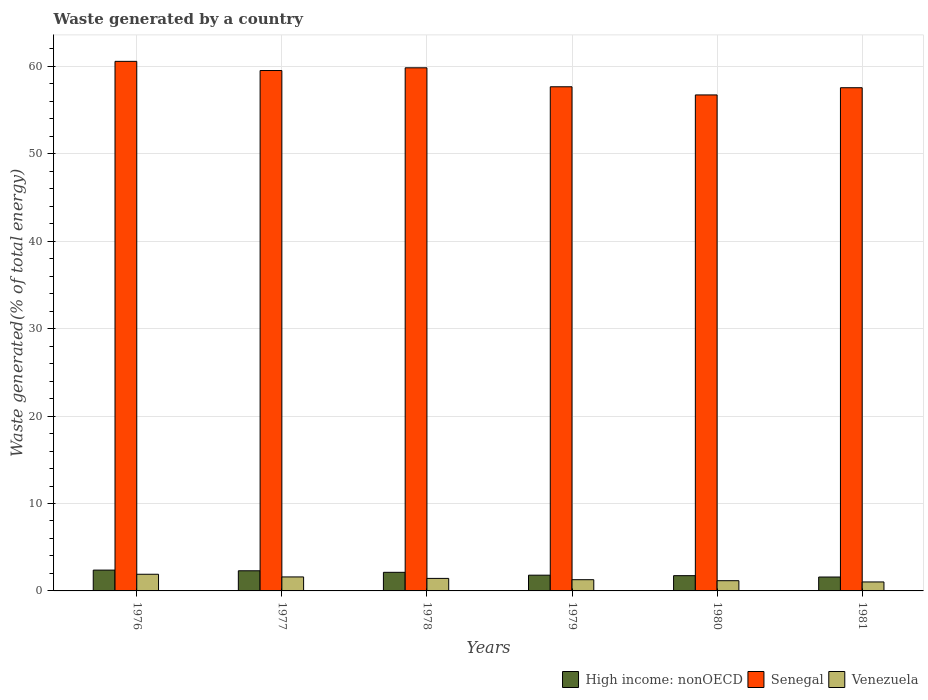How many different coloured bars are there?
Your answer should be compact. 3. How many groups of bars are there?
Your answer should be very brief. 6. Are the number of bars per tick equal to the number of legend labels?
Your response must be concise. Yes. How many bars are there on the 4th tick from the right?
Your response must be concise. 3. What is the label of the 2nd group of bars from the left?
Offer a very short reply. 1977. In how many cases, is the number of bars for a given year not equal to the number of legend labels?
Provide a short and direct response. 0. What is the total waste generated in Senegal in 1981?
Ensure brevity in your answer.  57.56. Across all years, what is the maximum total waste generated in Venezuela?
Offer a terse response. 1.91. Across all years, what is the minimum total waste generated in Senegal?
Ensure brevity in your answer.  56.74. In which year was the total waste generated in Venezuela maximum?
Provide a succinct answer. 1976. What is the total total waste generated in High income: nonOECD in the graph?
Make the answer very short. 11.95. What is the difference between the total waste generated in High income: nonOECD in 1976 and that in 1981?
Ensure brevity in your answer.  0.79. What is the difference between the total waste generated in Venezuela in 1976 and the total waste generated in Senegal in 1978?
Provide a succinct answer. -57.94. What is the average total waste generated in Venezuela per year?
Your answer should be compact. 1.4. In the year 1980, what is the difference between the total waste generated in Senegal and total waste generated in High income: nonOECD?
Give a very brief answer. 55. What is the ratio of the total waste generated in High income: nonOECD in 1976 to that in 1981?
Offer a terse response. 1.5. Is the difference between the total waste generated in Senegal in 1977 and 1978 greater than the difference between the total waste generated in High income: nonOECD in 1977 and 1978?
Provide a short and direct response. No. What is the difference between the highest and the second highest total waste generated in Senegal?
Your answer should be very brief. 0.74. What is the difference between the highest and the lowest total waste generated in High income: nonOECD?
Keep it short and to the point. 0.79. In how many years, is the total waste generated in High income: nonOECD greater than the average total waste generated in High income: nonOECD taken over all years?
Your response must be concise. 3. Is the sum of the total waste generated in High income: nonOECD in 1978 and 1981 greater than the maximum total waste generated in Venezuela across all years?
Make the answer very short. Yes. What does the 2nd bar from the left in 1977 represents?
Give a very brief answer. Senegal. What does the 2nd bar from the right in 1978 represents?
Offer a very short reply. Senegal. Is it the case that in every year, the sum of the total waste generated in Senegal and total waste generated in High income: nonOECD is greater than the total waste generated in Venezuela?
Your response must be concise. Yes. Are all the bars in the graph horizontal?
Keep it short and to the point. No. Does the graph contain grids?
Keep it short and to the point. Yes. How many legend labels are there?
Ensure brevity in your answer.  3. What is the title of the graph?
Your answer should be compact. Waste generated by a country. Does "Myanmar" appear as one of the legend labels in the graph?
Provide a succinct answer. No. What is the label or title of the X-axis?
Your response must be concise. Years. What is the label or title of the Y-axis?
Your response must be concise. Waste generated(% of total energy). What is the Waste generated(% of total energy) in High income: nonOECD in 1976?
Provide a short and direct response. 2.38. What is the Waste generated(% of total energy) in Senegal in 1976?
Keep it short and to the point. 60.58. What is the Waste generated(% of total energy) in Venezuela in 1976?
Offer a very short reply. 1.91. What is the Waste generated(% of total energy) in High income: nonOECD in 1977?
Offer a very short reply. 2.3. What is the Waste generated(% of total energy) in Senegal in 1977?
Your answer should be compact. 59.53. What is the Waste generated(% of total energy) of Venezuela in 1977?
Offer a terse response. 1.6. What is the Waste generated(% of total energy) in High income: nonOECD in 1978?
Provide a short and direct response. 2.13. What is the Waste generated(% of total energy) of Senegal in 1978?
Offer a terse response. 59.84. What is the Waste generated(% of total energy) in Venezuela in 1978?
Make the answer very short. 1.43. What is the Waste generated(% of total energy) in High income: nonOECD in 1979?
Your answer should be very brief. 1.8. What is the Waste generated(% of total energy) in Senegal in 1979?
Keep it short and to the point. 57.67. What is the Waste generated(% of total energy) of Venezuela in 1979?
Your answer should be compact. 1.28. What is the Waste generated(% of total energy) of High income: nonOECD in 1980?
Provide a short and direct response. 1.75. What is the Waste generated(% of total energy) of Senegal in 1980?
Provide a succinct answer. 56.74. What is the Waste generated(% of total energy) of Venezuela in 1980?
Give a very brief answer. 1.17. What is the Waste generated(% of total energy) of High income: nonOECD in 1981?
Give a very brief answer. 1.59. What is the Waste generated(% of total energy) of Senegal in 1981?
Ensure brevity in your answer.  57.56. What is the Waste generated(% of total energy) in Venezuela in 1981?
Give a very brief answer. 1.03. Across all years, what is the maximum Waste generated(% of total energy) of High income: nonOECD?
Offer a terse response. 2.38. Across all years, what is the maximum Waste generated(% of total energy) of Senegal?
Your answer should be very brief. 60.58. Across all years, what is the maximum Waste generated(% of total energy) in Venezuela?
Offer a very short reply. 1.91. Across all years, what is the minimum Waste generated(% of total energy) of High income: nonOECD?
Give a very brief answer. 1.59. Across all years, what is the minimum Waste generated(% of total energy) of Senegal?
Keep it short and to the point. 56.74. Across all years, what is the minimum Waste generated(% of total energy) of Venezuela?
Your answer should be compact. 1.03. What is the total Waste generated(% of total energy) of High income: nonOECD in the graph?
Offer a very short reply. 11.95. What is the total Waste generated(% of total energy) in Senegal in the graph?
Your answer should be compact. 351.94. What is the total Waste generated(% of total energy) of Venezuela in the graph?
Provide a succinct answer. 8.42. What is the difference between the Waste generated(% of total energy) in High income: nonOECD in 1976 and that in 1977?
Give a very brief answer. 0.08. What is the difference between the Waste generated(% of total energy) in Senegal in 1976 and that in 1977?
Ensure brevity in your answer.  1.05. What is the difference between the Waste generated(% of total energy) in Venezuela in 1976 and that in 1977?
Your answer should be compact. 0.31. What is the difference between the Waste generated(% of total energy) of High income: nonOECD in 1976 and that in 1978?
Keep it short and to the point. 0.25. What is the difference between the Waste generated(% of total energy) in Senegal in 1976 and that in 1978?
Your answer should be compact. 0.74. What is the difference between the Waste generated(% of total energy) in Venezuela in 1976 and that in 1978?
Keep it short and to the point. 0.47. What is the difference between the Waste generated(% of total energy) in High income: nonOECD in 1976 and that in 1979?
Offer a terse response. 0.58. What is the difference between the Waste generated(% of total energy) of Senegal in 1976 and that in 1979?
Your response must be concise. 2.91. What is the difference between the Waste generated(% of total energy) of Venezuela in 1976 and that in 1979?
Make the answer very short. 0.62. What is the difference between the Waste generated(% of total energy) in High income: nonOECD in 1976 and that in 1980?
Your answer should be compact. 0.64. What is the difference between the Waste generated(% of total energy) of Senegal in 1976 and that in 1980?
Offer a very short reply. 3.84. What is the difference between the Waste generated(% of total energy) in Venezuela in 1976 and that in 1980?
Make the answer very short. 0.74. What is the difference between the Waste generated(% of total energy) of High income: nonOECD in 1976 and that in 1981?
Ensure brevity in your answer.  0.79. What is the difference between the Waste generated(% of total energy) in Senegal in 1976 and that in 1981?
Ensure brevity in your answer.  3.02. What is the difference between the Waste generated(% of total energy) in Venezuela in 1976 and that in 1981?
Give a very brief answer. 0.88. What is the difference between the Waste generated(% of total energy) of High income: nonOECD in 1977 and that in 1978?
Offer a terse response. 0.18. What is the difference between the Waste generated(% of total energy) in Senegal in 1977 and that in 1978?
Offer a terse response. -0.31. What is the difference between the Waste generated(% of total energy) of Venezuela in 1977 and that in 1978?
Offer a very short reply. 0.17. What is the difference between the Waste generated(% of total energy) in High income: nonOECD in 1977 and that in 1979?
Provide a succinct answer. 0.5. What is the difference between the Waste generated(% of total energy) of Senegal in 1977 and that in 1979?
Your response must be concise. 1.86. What is the difference between the Waste generated(% of total energy) of Venezuela in 1977 and that in 1979?
Make the answer very short. 0.32. What is the difference between the Waste generated(% of total energy) in High income: nonOECD in 1977 and that in 1980?
Offer a terse response. 0.56. What is the difference between the Waste generated(% of total energy) in Senegal in 1977 and that in 1980?
Ensure brevity in your answer.  2.79. What is the difference between the Waste generated(% of total energy) in Venezuela in 1977 and that in 1980?
Your response must be concise. 0.43. What is the difference between the Waste generated(% of total energy) of High income: nonOECD in 1977 and that in 1981?
Give a very brief answer. 0.72. What is the difference between the Waste generated(% of total energy) of Senegal in 1977 and that in 1981?
Make the answer very short. 1.97. What is the difference between the Waste generated(% of total energy) in Venezuela in 1977 and that in 1981?
Your response must be concise. 0.57. What is the difference between the Waste generated(% of total energy) of High income: nonOECD in 1978 and that in 1979?
Provide a succinct answer. 0.33. What is the difference between the Waste generated(% of total energy) of Senegal in 1978 and that in 1979?
Offer a very short reply. 2.17. What is the difference between the Waste generated(% of total energy) in Venezuela in 1978 and that in 1979?
Keep it short and to the point. 0.15. What is the difference between the Waste generated(% of total energy) of High income: nonOECD in 1978 and that in 1980?
Make the answer very short. 0.38. What is the difference between the Waste generated(% of total energy) in Senegal in 1978 and that in 1980?
Your answer should be very brief. 3.1. What is the difference between the Waste generated(% of total energy) in Venezuela in 1978 and that in 1980?
Ensure brevity in your answer.  0.26. What is the difference between the Waste generated(% of total energy) of High income: nonOECD in 1978 and that in 1981?
Ensure brevity in your answer.  0.54. What is the difference between the Waste generated(% of total energy) of Senegal in 1978 and that in 1981?
Provide a short and direct response. 2.28. What is the difference between the Waste generated(% of total energy) of Venezuela in 1978 and that in 1981?
Give a very brief answer. 0.41. What is the difference between the Waste generated(% of total energy) of High income: nonOECD in 1979 and that in 1980?
Offer a terse response. 0.05. What is the difference between the Waste generated(% of total energy) in Senegal in 1979 and that in 1980?
Your answer should be very brief. 0.93. What is the difference between the Waste generated(% of total energy) in Venezuela in 1979 and that in 1980?
Your answer should be compact. 0.11. What is the difference between the Waste generated(% of total energy) of High income: nonOECD in 1979 and that in 1981?
Ensure brevity in your answer.  0.21. What is the difference between the Waste generated(% of total energy) of Senegal in 1979 and that in 1981?
Ensure brevity in your answer.  0.11. What is the difference between the Waste generated(% of total energy) in Venezuela in 1979 and that in 1981?
Ensure brevity in your answer.  0.26. What is the difference between the Waste generated(% of total energy) of High income: nonOECD in 1980 and that in 1981?
Keep it short and to the point. 0.16. What is the difference between the Waste generated(% of total energy) of Senegal in 1980 and that in 1981?
Provide a succinct answer. -0.82. What is the difference between the Waste generated(% of total energy) in Venezuela in 1980 and that in 1981?
Provide a short and direct response. 0.14. What is the difference between the Waste generated(% of total energy) of High income: nonOECD in 1976 and the Waste generated(% of total energy) of Senegal in 1977?
Make the answer very short. -57.15. What is the difference between the Waste generated(% of total energy) of High income: nonOECD in 1976 and the Waste generated(% of total energy) of Venezuela in 1977?
Offer a very short reply. 0.78. What is the difference between the Waste generated(% of total energy) of Senegal in 1976 and the Waste generated(% of total energy) of Venezuela in 1977?
Make the answer very short. 58.98. What is the difference between the Waste generated(% of total energy) in High income: nonOECD in 1976 and the Waste generated(% of total energy) in Senegal in 1978?
Give a very brief answer. -57.46. What is the difference between the Waste generated(% of total energy) of High income: nonOECD in 1976 and the Waste generated(% of total energy) of Venezuela in 1978?
Offer a terse response. 0.95. What is the difference between the Waste generated(% of total energy) in Senegal in 1976 and the Waste generated(% of total energy) in Venezuela in 1978?
Ensure brevity in your answer.  59.15. What is the difference between the Waste generated(% of total energy) of High income: nonOECD in 1976 and the Waste generated(% of total energy) of Senegal in 1979?
Your response must be concise. -55.29. What is the difference between the Waste generated(% of total energy) in High income: nonOECD in 1976 and the Waste generated(% of total energy) in Venezuela in 1979?
Provide a short and direct response. 1.1. What is the difference between the Waste generated(% of total energy) in Senegal in 1976 and the Waste generated(% of total energy) in Venezuela in 1979?
Your answer should be compact. 59.3. What is the difference between the Waste generated(% of total energy) in High income: nonOECD in 1976 and the Waste generated(% of total energy) in Senegal in 1980?
Give a very brief answer. -54.36. What is the difference between the Waste generated(% of total energy) of High income: nonOECD in 1976 and the Waste generated(% of total energy) of Venezuela in 1980?
Your answer should be compact. 1.21. What is the difference between the Waste generated(% of total energy) in Senegal in 1976 and the Waste generated(% of total energy) in Venezuela in 1980?
Give a very brief answer. 59.41. What is the difference between the Waste generated(% of total energy) of High income: nonOECD in 1976 and the Waste generated(% of total energy) of Senegal in 1981?
Your answer should be very brief. -55.18. What is the difference between the Waste generated(% of total energy) of High income: nonOECD in 1976 and the Waste generated(% of total energy) of Venezuela in 1981?
Give a very brief answer. 1.36. What is the difference between the Waste generated(% of total energy) in Senegal in 1976 and the Waste generated(% of total energy) in Venezuela in 1981?
Your response must be concise. 59.56. What is the difference between the Waste generated(% of total energy) in High income: nonOECD in 1977 and the Waste generated(% of total energy) in Senegal in 1978?
Your response must be concise. -57.54. What is the difference between the Waste generated(% of total energy) of High income: nonOECD in 1977 and the Waste generated(% of total energy) of Venezuela in 1978?
Ensure brevity in your answer.  0.87. What is the difference between the Waste generated(% of total energy) of Senegal in 1977 and the Waste generated(% of total energy) of Venezuela in 1978?
Your answer should be compact. 58.1. What is the difference between the Waste generated(% of total energy) of High income: nonOECD in 1977 and the Waste generated(% of total energy) of Senegal in 1979?
Provide a short and direct response. -55.37. What is the difference between the Waste generated(% of total energy) of High income: nonOECD in 1977 and the Waste generated(% of total energy) of Venezuela in 1979?
Offer a terse response. 1.02. What is the difference between the Waste generated(% of total energy) of Senegal in 1977 and the Waste generated(% of total energy) of Venezuela in 1979?
Provide a succinct answer. 58.25. What is the difference between the Waste generated(% of total energy) of High income: nonOECD in 1977 and the Waste generated(% of total energy) of Senegal in 1980?
Give a very brief answer. -54.44. What is the difference between the Waste generated(% of total energy) in High income: nonOECD in 1977 and the Waste generated(% of total energy) in Venezuela in 1980?
Your answer should be compact. 1.14. What is the difference between the Waste generated(% of total energy) of Senegal in 1977 and the Waste generated(% of total energy) of Venezuela in 1980?
Offer a terse response. 58.36. What is the difference between the Waste generated(% of total energy) in High income: nonOECD in 1977 and the Waste generated(% of total energy) in Senegal in 1981?
Provide a succinct answer. -55.26. What is the difference between the Waste generated(% of total energy) of High income: nonOECD in 1977 and the Waste generated(% of total energy) of Venezuela in 1981?
Offer a terse response. 1.28. What is the difference between the Waste generated(% of total energy) of Senegal in 1977 and the Waste generated(% of total energy) of Venezuela in 1981?
Keep it short and to the point. 58.51. What is the difference between the Waste generated(% of total energy) of High income: nonOECD in 1978 and the Waste generated(% of total energy) of Senegal in 1979?
Your answer should be compact. -55.55. What is the difference between the Waste generated(% of total energy) in High income: nonOECD in 1978 and the Waste generated(% of total energy) in Venezuela in 1979?
Provide a succinct answer. 0.84. What is the difference between the Waste generated(% of total energy) of Senegal in 1978 and the Waste generated(% of total energy) of Venezuela in 1979?
Ensure brevity in your answer.  58.56. What is the difference between the Waste generated(% of total energy) in High income: nonOECD in 1978 and the Waste generated(% of total energy) in Senegal in 1980?
Ensure brevity in your answer.  -54.61. What is the difference between the Waste generated(% of total energy) of High income: nonOECD in 1978 and the Waste generated(% of total energy) of Venezuela in 1980?
Offer a terse response. 0.96. What is the difference between the Waste generated(% of total energy) in Senegal in 1978 and the Waste generated(% of total energy) in Venezuela in 1980?
Ensure brevity in your answer.  58.68. What is the difference between the Waste generated(% of total energy) of High income: nonOECD in 1978 and the Waste generated(% of total energy) of Senegal in 1981?
Your answer should be compact. -55.44. What is the difference between the Waste generated(% of total energy) of High income: nonOECD in 1978 and the Waste generated(% of total energy) of Venezuela in 1981?
Ensure brevity in your answer.  1.1. What is the difference between the Waste generated(% of total energy) in Senegal in 1978 and the Waste generated(% of total energy) in Venezuela in 1981?
Your response must be concise. 58.82. What is the difference between the Waste generated(% of total energy) in High income: nonOECD in 1979 and the Waste generated(% of total energy) in Senegal in 1980?
Offer a very short reply. -54.94. What is the difference between the Waste generated(% of total energy) in High income: nonOECD in 1979 and the Waste generated(% of total energy) in Venezuela in 1980?
Offer a very short reply. 0.63. What is the difference between the Waste generated(% of total energy) of Senegal in 1979 and the Waste generated(% of total energy) of Venezuela in 1980?
Make the answer very short. 56.51. What is the difference between the Waste generated(% of total energy) of High income: nonOECD in 1979 and the Waste generated(% of total energy) of Senegal in 1981?
Your response must be concise. -55.76. What is the difference between the Waste generated(% of total energy) in High income: nonOECD in 1979 and the Waste generated(% of total energy) in Venezuela in 1981?
Provide a succinct answer. 0.78. What is the difference between the Waste generated(% of total energy) of Senegal in 1979 and the Waste generated(% of total energy) of Venezuela in 1981?
Offer a very short reply. 56.65. What is the difference between the Waste generated(% of total energy) in High income: nonOECD in 1980 and the Waste generated(% of total energy) in Senegal in 1981?
Ensure brevity in your answer.  -55.82. What is the difference between the Waste generated(% of total energy) of High income: nonOECD in 1980 and the Waste generated(% of total energy) of Venezuela in 1981?
Your answer should be very brief. 0.72. What is the difference between the Waste generated(% of total energy) in Senegal in 1980 and the Waste generated(% of total energy) in Venezuela in 1981?
Provide a short and direct response. 55.72. What is the average Waste generated(% of total energy) of High income: nonOECD per year?
Your answer should be compact. 1.99. What is the average Waste generated(% of total energy) in Senegal per year?
Make the answer very short. 58.66. What is the average Waste generated(% of total energy) of Venezuela per year?
Make the answer very short. 1.4. In the year 1976, what is the difference between the Waste generated(% of total energy) in High income: nonOECD and Waste generated(% of total energy) in Senegal?
Offer a very short reply. -58.2. In the year 1976, what is the difference between the Waste generated(% of total energy) in High income: nonOECD and Waste generated(% of total energy) in Venezuela?
Provide a succinct answer. 0.48. In the year 1976, what is the difference between the Waste generated(% of total energy) of Senegal and Waste generated(% of total energy) of Venezuela?
Offer a terse response. 58.68. In the year 1977, what is the difference between the Waste generated(% of total energy) of High income: nonOECD and Waste generated(% of total energy) of Senegal?
Your answer should be compact. -57.23. In the year 1977, what is the difference between the Waste generated(% of total energy) in High income: nonOECD and Waste generated(% of total energy) in Venezuela?
Make the answer very short. 0.71. In the year 1977, what is the difference between the Waste generated(% of total energy) in Senegal and Waste generated(% of total energy) in Venezuela?
Make the answer very short. 57.93. In the year 1978, what is the difference between the Waste generated(% of total energy) in High income: nonOECD and Waste generated(% of total energy) in Senegal?
Give a very brief answer. -57.72. In the year 1978, what is the difference between the Waste generated(% of total energy) in High income: nonOECD and Waste generated(% of total energy) in Venezuela?
Offer a terse response. 0.7. In the year 1978, what is the difference between the Waste generated(% of total energy) in Senegal and Waste generated(% of total energy) in Venezuela?
Ensure brevity in your answer.  58.41. In the year 1979, what is the difference between the Waste generated(% of total energy) in High income: nonOECD and Waste generated(% of total energy) in Senegal?
Provide a short and direct response. -55.87. In the year 1979, what is the difference between the Waste generated(% of total energy) of High income: nonOECD and Waste generated(% of total energy) of Venezuela?
Offer a terse response. 0.52. In the year 1979, what is the difference between the Waste generated(% of total energy) in Senegal and Waste generated(% of total energy) in Venezuela?
Ensure brevity in your answer.  56.39. In the year 1980, what is the difference between the Waste generated(% of total energy) in High income: nonOECD and Waste generated(% of total energy) in Senegal?
Provide a succinct answer. -55. In the year 1980, what is the difference between the Waste generated(% of total energy) in High income: nonOECD and Waste generated(% of total energy) in Venezuela?
Give a very brief answer. 0.58. In the year 1980, what is the difference between the Waste generated(% of total energy) of Senegal and Waste generated(% of total energy) of Venezuela?
Offer a very short reply. 55.57. In the year 1981, what is the difference between the Waste generated(% of total energy) in High income: nonOECD and Waste generated(% of total energy) in Senegal?
Keep it short and to the point. -55.98. In the year 1981, what is the difference between the Waste generated(% of total energy) of High income: nonOECD and Waste generated(% of total energy) of Venezuela?
Give a very brief answer. 0.56. In the year 1981, what is the difference between the Waste generated(% of total energy) in Senegal and Waste generated(% of total energy) in Venezuela?
Provide a short and direct response. 56.54. What is the ratio of the Waste generated(% of total energy) of Senegal in 1976 to that in 1977?
Offer a very short reply. 1.02. What is the ratio of the Waste generated(% of total energy) in Venezuela in 1976 to that in 1977?
Keep it short and to the point. 1.19. What is the ratio of the Waste generated(% of total energy) in High income: nonOECD in 1976 to that in 1978?
Your response must be concise. 1.12. What is the ratio of the Waste generated(% of total energy) in Senegal in 1976 to that in 1978?
Keep it short and to the point. 1.01. What is the ratio of the Waste generated(% of total energy) in Venezuela in 1976 to that in 1978?
Give a very brief answer. 1.33. What is the ratio of the Waste generated(% of total energy) in High income: nonOECD in 1976 to that in 1979?
Offer a terse response. 1.32. What is the ratio of the Waste generated(% of total energy) in Senegal in 1976 to that in 1979?
Your answer should be compact. 1.05. What is the ratio of the Waste generated(% of total energy) of Venezuela in 1976 to that in 1979?
Your response must be concise. 1.48. What is the ratio of the Waste generated(% of total energy) in High income: nonOECD in 1976 to that in 1980?
Offer a very short reply. 1.36. What is the ratio of the Waste generated(% of total energy) of Senegal in 1976 to that in 1980?
Your answer should be very brief. 1.07. What is the ratio of the Waste generated(% of total energy) in Venezuela in 1976 to that in 1980?
Your response must be concise. 1.63. What is the ratio of the Waste generated(% of total energy) in High income: nonOECD in 1976 to that in 1981?
Your answer should be compact. 1.5. What is the ratio of the Waste generated(% of total energy) of Senegal in 1976 to that in 1981?
Your response must be concise. 1.05. What is the ratio of the Waste generated(% of total energy) in Venezuela in 1976 to that in 1981?
Provide a succinct answer. 1.86. What is the ratio of the Waste generated(% of total energy) in High income: nonOECD in 1977 to that in 1978?
Offer a terse response. 1.08. What is the ratio of the Waste generated(% of total energy) in Senegal in 1977 to that in 1978?
Give a very brief answer. 0.99. What is the ratio of the Waste generated(% of total energy) in Venezuela in 1977 to that in 1978?
Ensure brevity in your answer.  1.12. What is the ratio of the Waste generated(% of total energy) in High income: nonOECD in 1977 to that in 1979?
Your response must be concise. 1.28. What is the ratio of the Waste generated(% of total energy) in Senegal in 1977 to that in 1979?
Your response must be concise. 1.03. What is the ratio of the Waste generated(% of total energy) of Venezuela in 1977 to that in 1979?
Offer a terse response. 1.25. What is the ratio of the Waste generated(% of total energy) of High income: nonOECD in 1977 to that in 1980?
Your response must be concise. 1.32. What is the ratio of the Waste generated(% of total energy) of Senegal in 1977 to that in 1980?
Your response must be concise. 1.05. What is the ratio of the Waste generated(% of total energy) in Venezuela in 1977 to that in 1980?
Make the answer very short. 1.37. What is the ratio of the Waste generated(% of total energy) of High income: nonOECD in 1977 to that in 1981?
Your answer should be compact. 1.45. What is the ratio of the Waste generated(% of total energy) in Senegal in 1977 to that in 1981?
Your response must be concise. 1.03. What is the ratio of the Waste generated(% of total energy) in Venezuela in 1977 to that in 1981?
Offer a terse response. 1.56. What is the ratio of the Waste generated(% of total energy) in High income: nonOECD in 1978 to that in 1979?
Your response must be concise. 1.18. What is the ratio of the Waste generated(% of total energy) in Senegal in 1978 to that in 1979?
Your answer should be compact. 1.04. What is the ratio of the Waste generated(% of total energy) in Venezuela in 1978 to that in 1979?
Provide a short and direct response. 1.12. What is the ratio of the Waste generated(% of total energy) in High income: nonOECD in 1978 to that in 1980?
Your response must be concise. 1.22. What is the ratio of the Waste generated(% of total energy) in Senegal in 1978 to that in 1980?
Your answer should be compact. 1.05. What is the ratio of the Waste generated(% of total energy) of Venezuela in 1978 to that in 1980?
Keep it short and to the point. 1.23. What is the ratio of the Waste generated(% of total energy) in High income: nonOECD in 1978 to that in 1981?
Offer a terse response. 1.34. What is the ratio of the Waste generated(% of total energy) in Senegal in 1978 to that in 1981?
Keep it short and to the point. 1.04. What is the ratio of the Waste generated(% of total energy) in Venezuela in 1978 to that in 1981?
Your answer should be compact. 1.4. What is the ratio of the Waste generated(% of total energy) of High income: nonOECD in 1979 to that in 1980?
Your answer should be compact. 1.03. What is the ratio of the Waste generated(% of total energy) in Senegal in 1979 to that in 1980?
Offer a very short reply. 1.02. What is the ratio of the Waste generated(% of total energy) of Venezuela in 1979 to that in 1980?
Your answer should be compact. 1.1. What is the ratio of the Waste generated(% of total energy) of High income: nonOECD in 1979 to that in 1981?
Give a very brief answer. 1.13. What is the ratio of the Waste generated(% of total energy) in Venezuela in 1979 to that in 1981?
Provide a succinct answer. 1.25. What is the ratio of the Waste generated(% of total energy) of High income: nonOECD in 1980 to that in 1981?
Provide a succinct answer. 1.1. What is the ratio of the Waste generated(% of total energy) in Senegal in 1980 to that in 1981?
Ensure brevity in your answer.  0.99. What is the ratio of the Waste generated(% of total energy) of Venezuela in 1980 to that in 1981?
Make the answer very short. 1.14. What is the difference between the highest and the second highest Waste generated(% of total energy) in High income: nonOECD?
Offer a very short reply. 0.08. What is the difference between the highest and the second highest Waste generated(% of total energy) of Senegal?
Make the answer very short. 0.74. What is the difference between the highest and the second highest Waste generated(% of total energy) of Venezuela?
Ensure brevity in your answer.  0.31. What is the difference between the highest and the lowest Waste generated(% of total energy) in High income: nonOECD?
Make the answer very short. 0.79. What is the difference between the highest and the lowest Waste generated(% of total energy) of Senegal?
Offer a very short reply. 3.84. What is the difference between the highest and the lowest Waste generated(% of total energy) of Venezuela?
Your answer should be very brief. 0.88. 